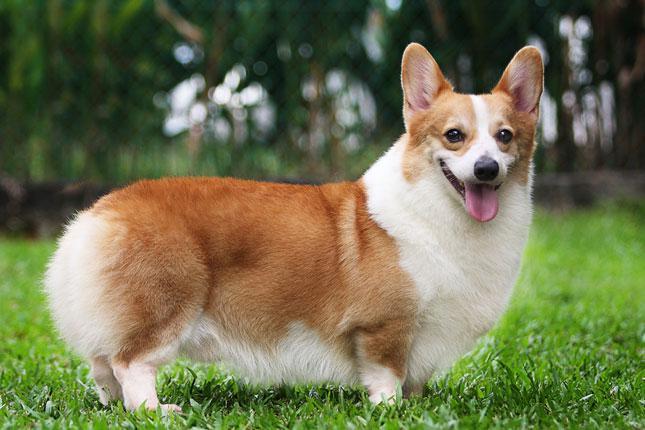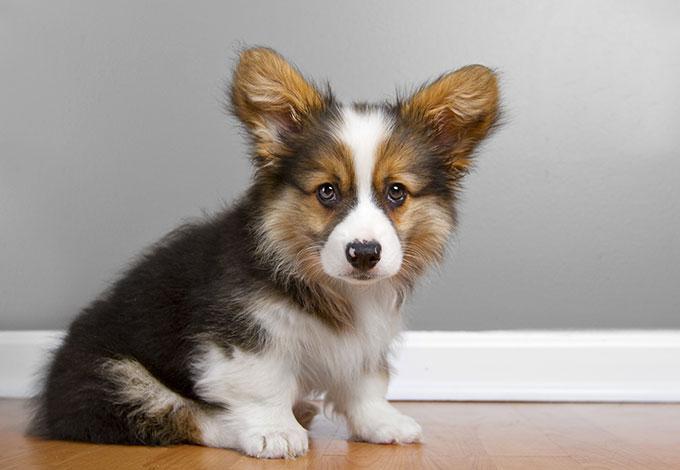The first image is the image on the left, the second image is the image on the right. Considering the images on both sides, is "The righthand image contains a single dog, which is tri-colored and sitting upright, with its mouth closed." valid? Answer yes or no. Yes. The first image is the image on the left, the second image is the image on the right. For the images displayed, is the sentence "There is exactly three puppies." factually correct? Answer yes or no. No. 